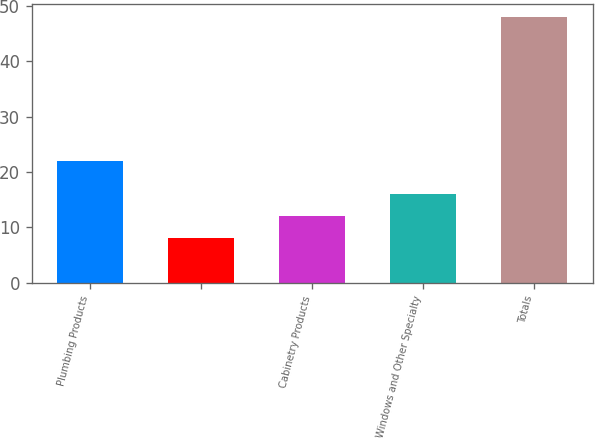<chart> <loc_0><loc_0><loc_500><loc_500><bar_chart><fcel>Plumbing Products<fcel>Unnamed: 1<fcel>Cabinetry Products<fcel>Windows and Other Specialty<fcel>Totals<nl><fcel>22<fcel>8<fcel>12<fcel>16<fcel>48<nl></chart> 